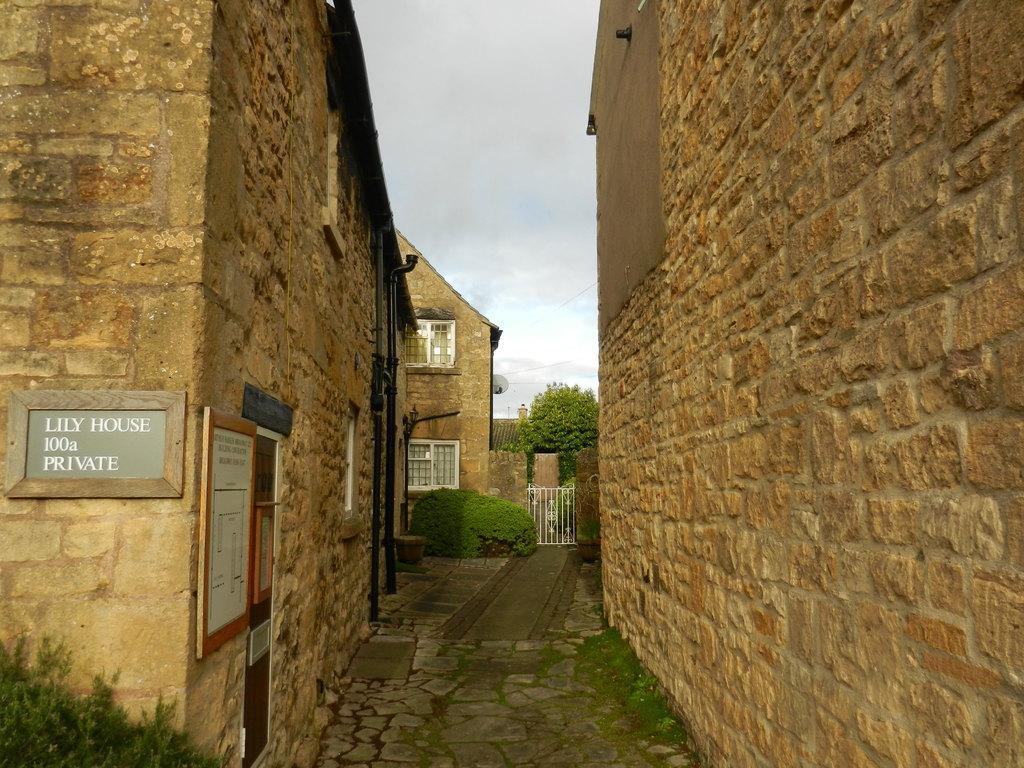Can you describe this image briefly? On the eight and left side of the image there are buildings with bricks and some nameplates hanging on the wall, in the middle of them there is a path, in front of the buildings there are trees. In the background there is a sky. 